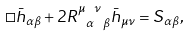Convert formula to latex. <formula><loc_0><loc_0><loc_500><loc_500>\square \bar { h } _ { \alpha \beta } + 2 R ^ { \mu \ \nu } _ { \ \alpha \ \beta } \bar { h } _ { \mu \nu } = S _ { \alpha \beta } ,</formula> 